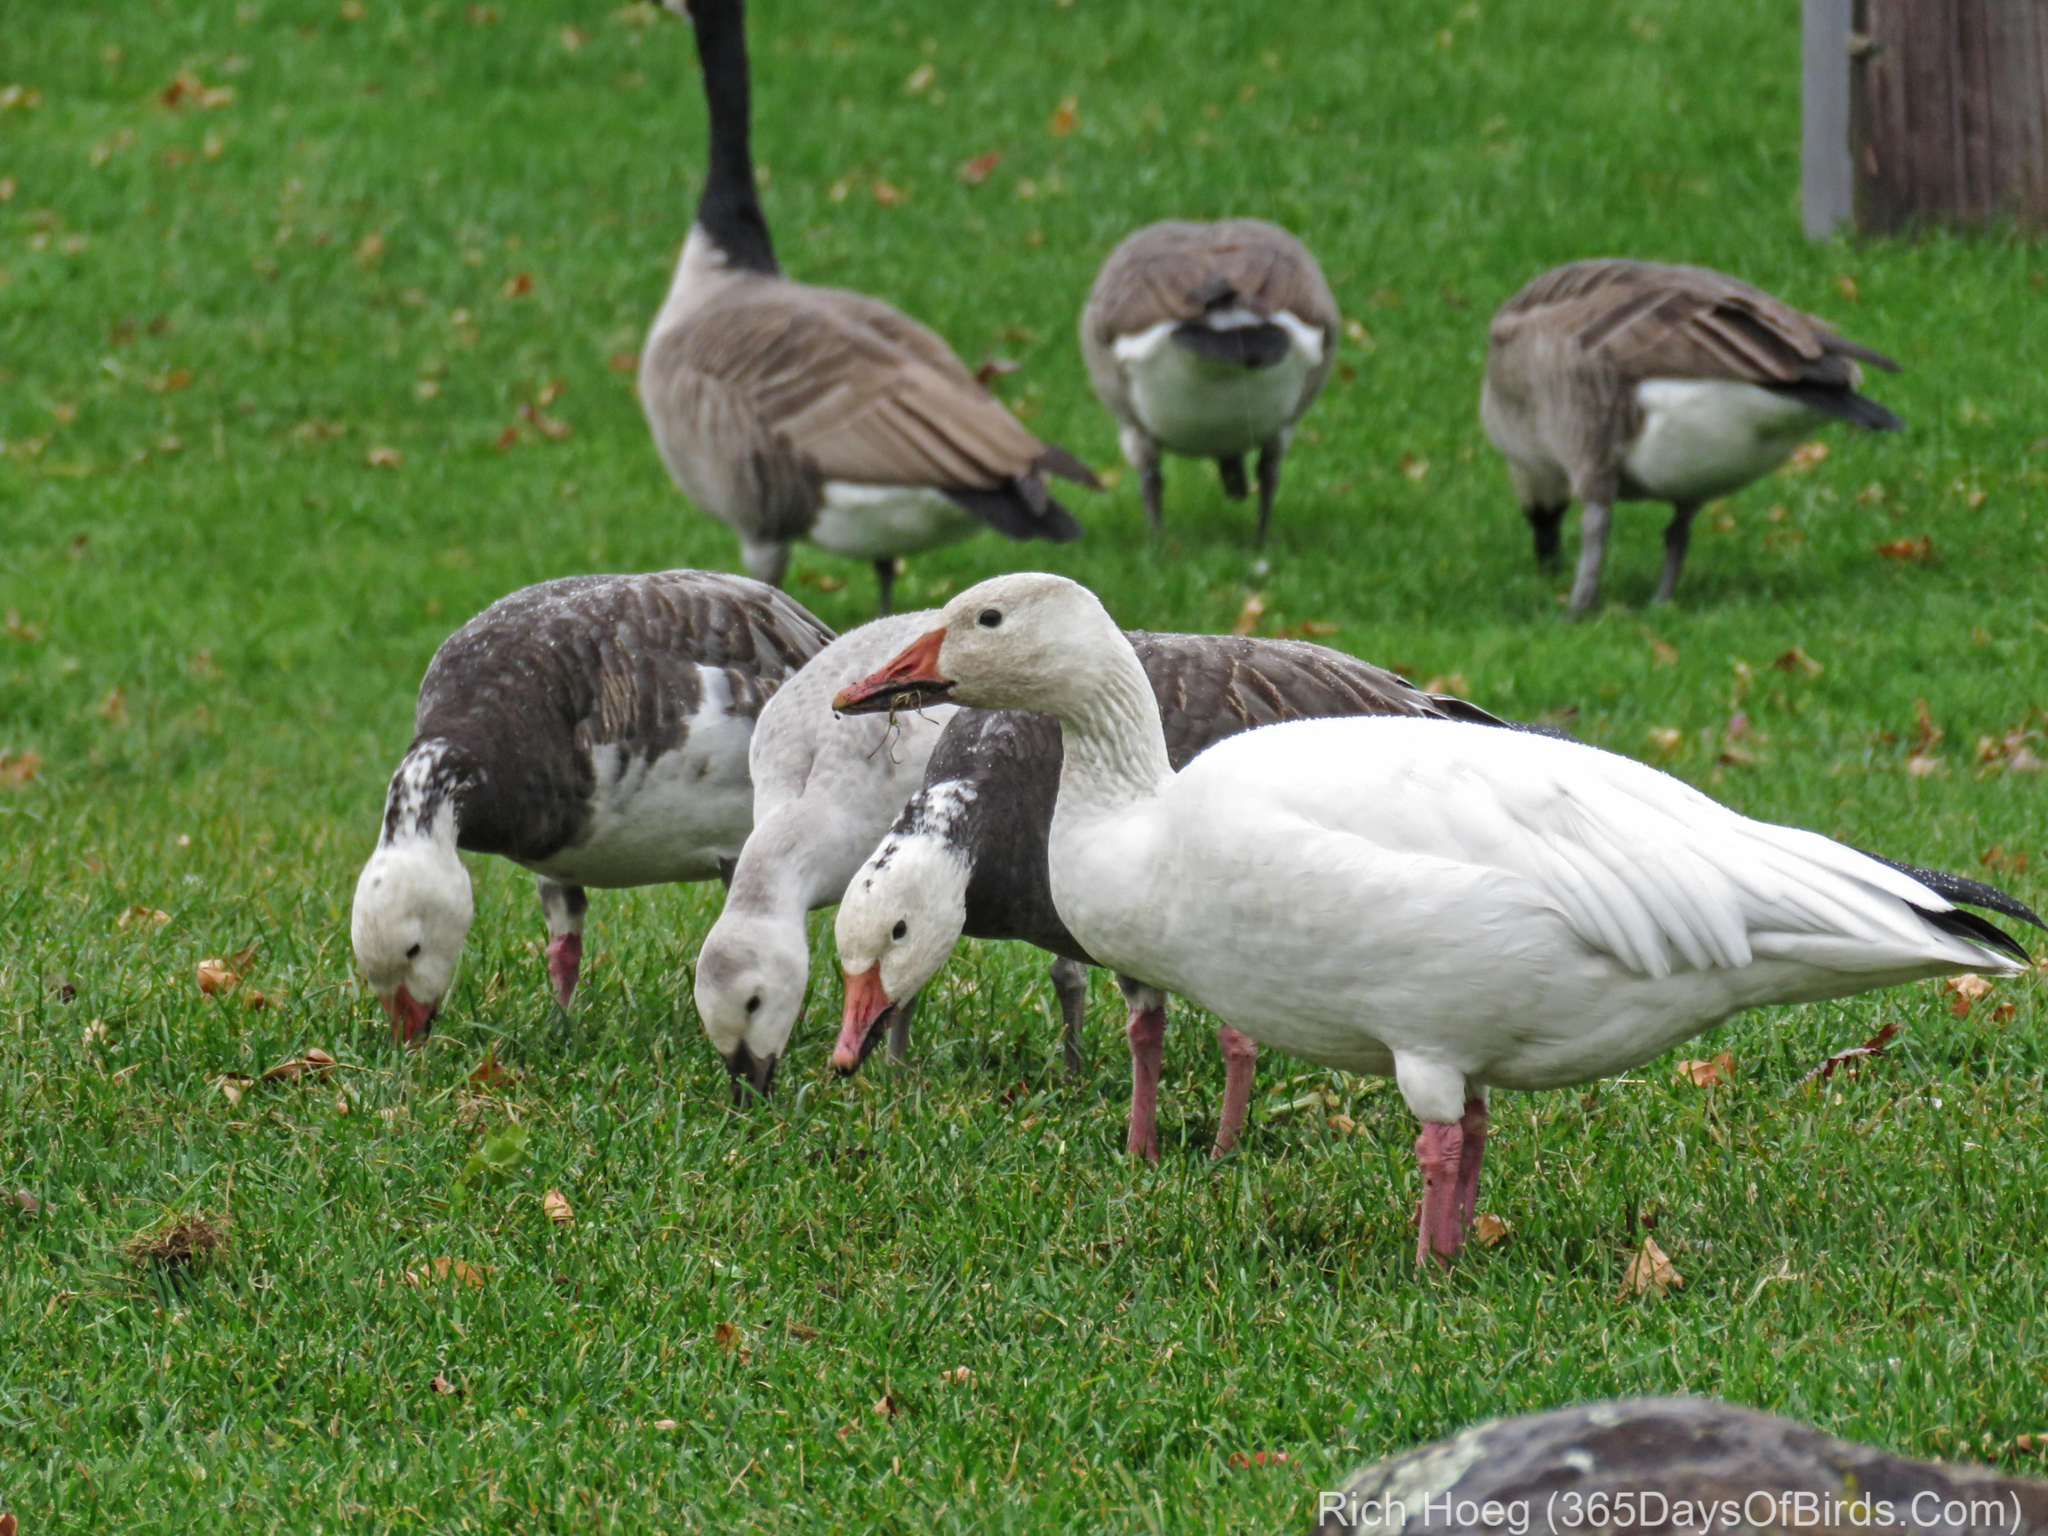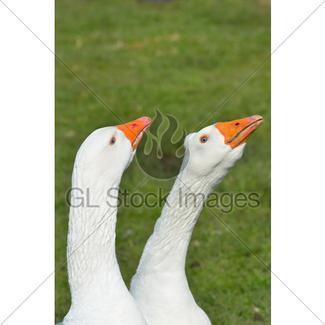The first image is the image on the left, the second image is the image on the right. For the images displayed, is the sentence "All ducks shown are white, and no image includes fuzzy ducklings." factually correct? Answer yes or no. No. The first image is the image on the left, the second image is the image on the right. Considering the images on both sides, is "The left image contains exactly two white ducks." valid? Answer yes or no. No. 